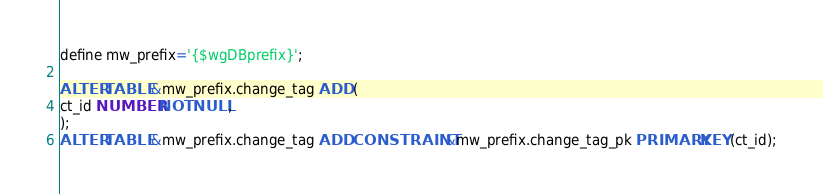<code> <loc_0><loc_0><loc_500><loc_500><_SQL_>define mw_prefix='{$wgDBprefix}';

ALTER TABLE &mw_prefix.change_tag ADD (
ct_id NUMBER NOT NULL,
);
ALTER TABLE &mw_prefix.change_tag ADD CONSTRAINT &mw_prefix.change_tag_pk PRIMARY KEY (ct_id);
</code> 